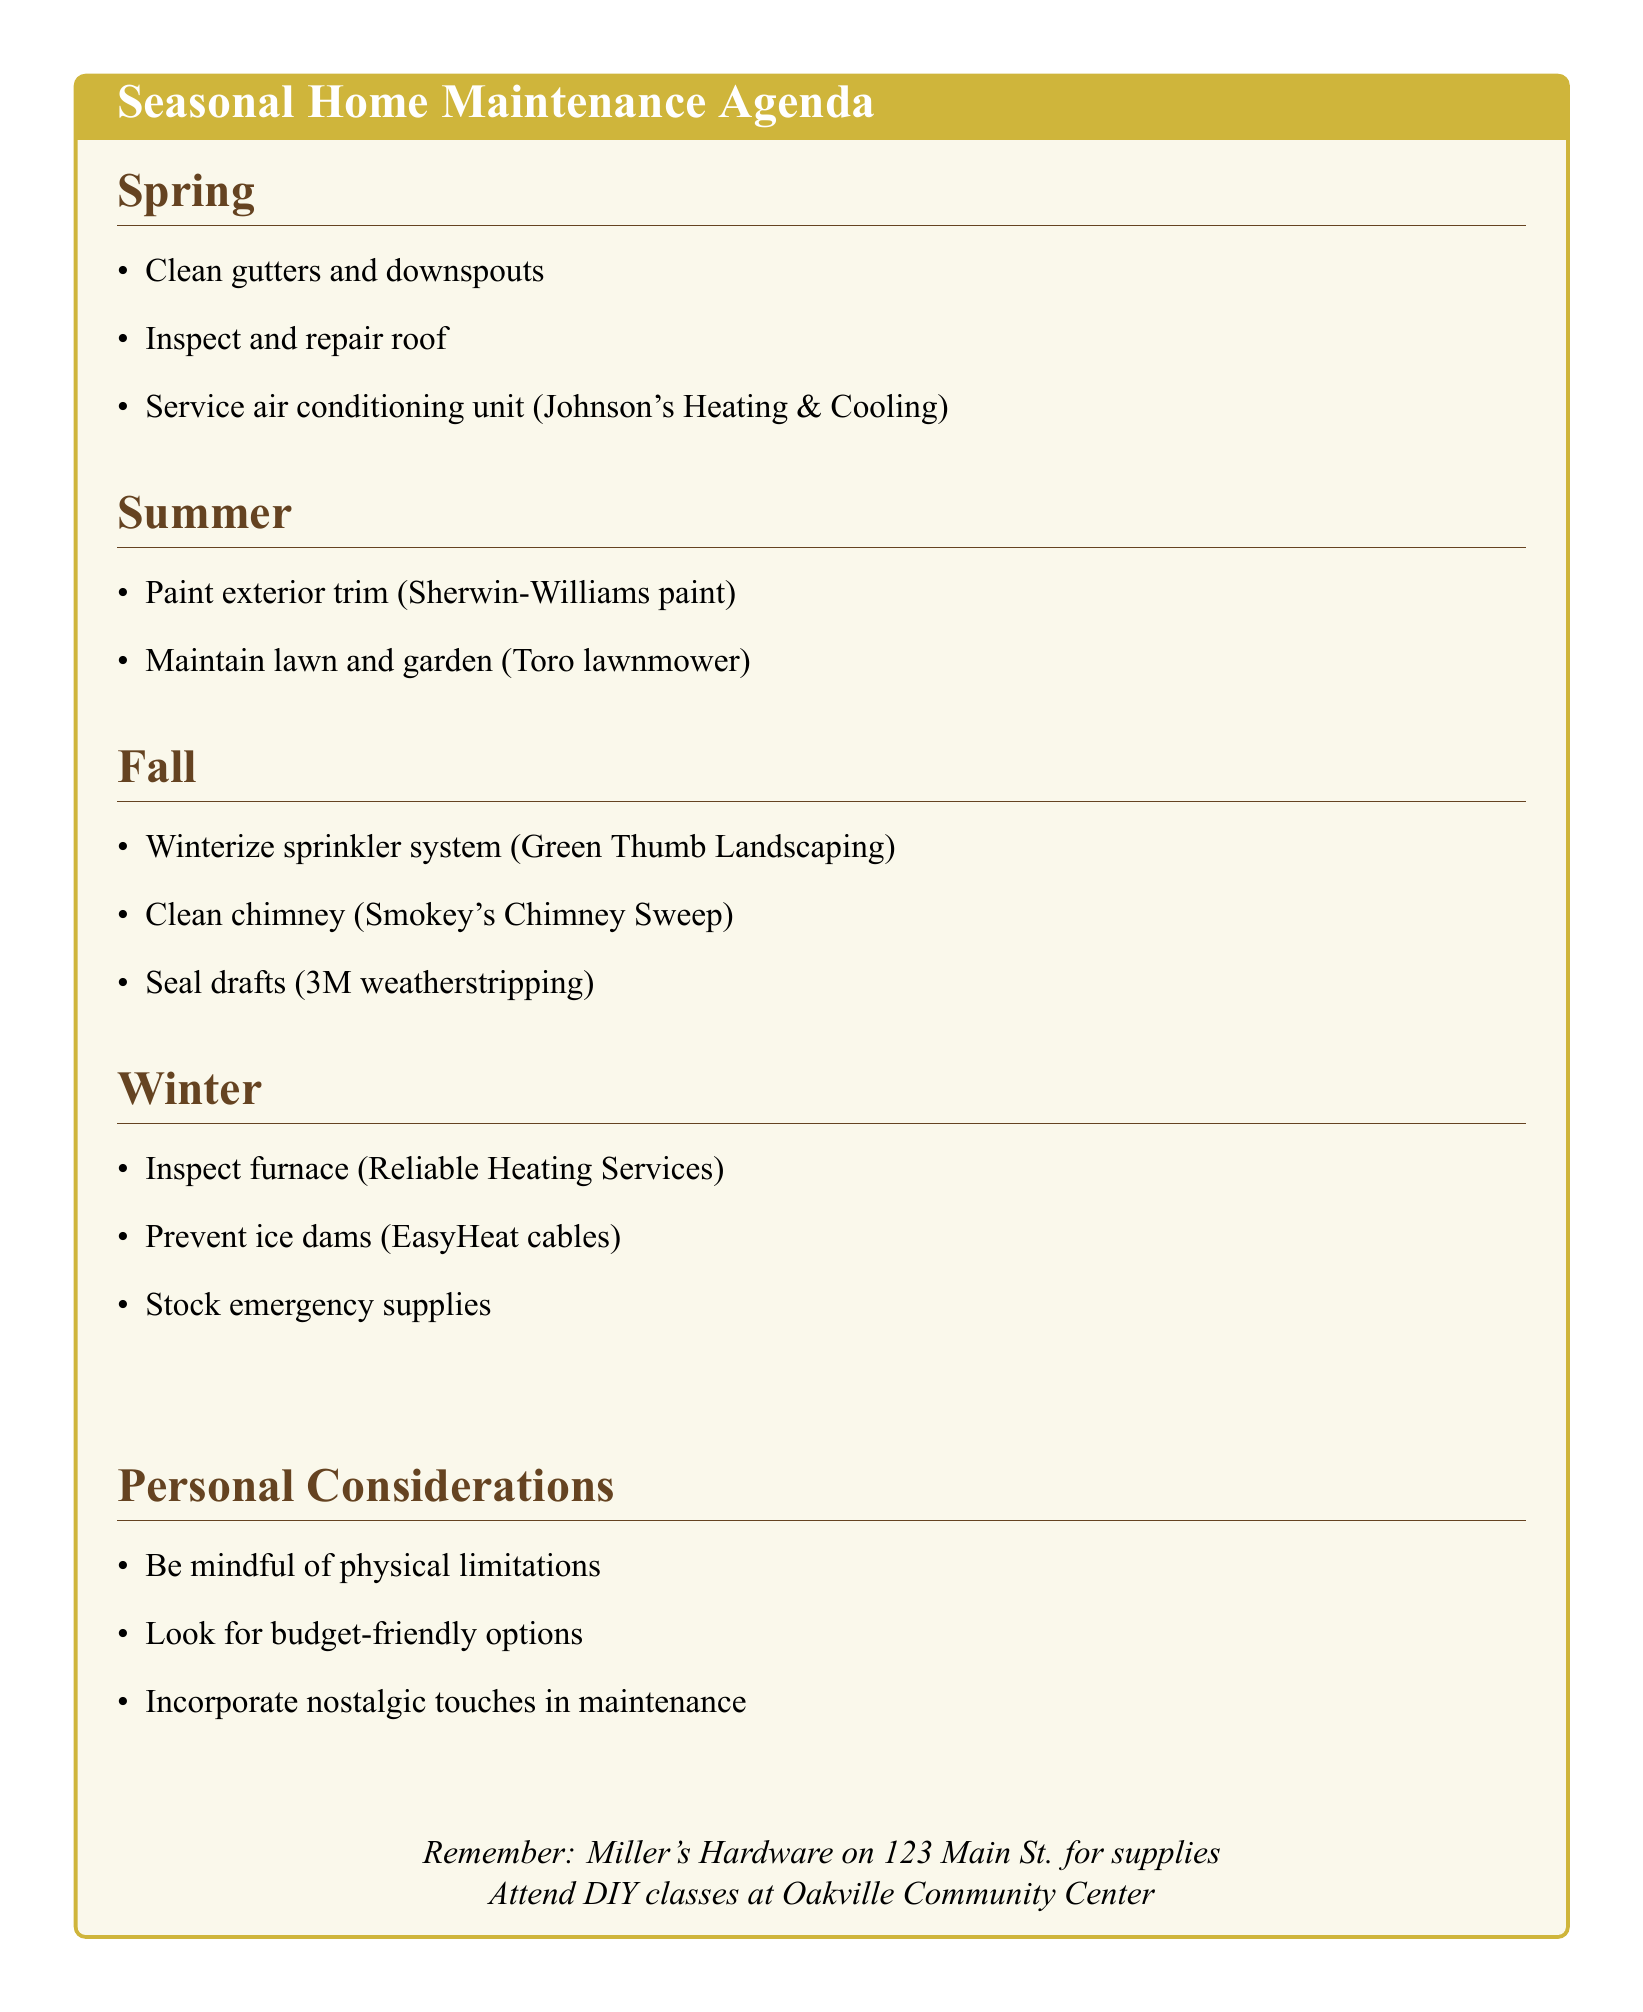what is the first spring task listed? The first task listed under spring is to clean gutters and downspouts.
Answer: Clean gutters and downspouts which service provider is mentioned for the AC maintenance? The document states that Johnson's Heating & Cooling is the service provider for AC maintenance.
Answer: Johnson's Heating & Cooling how many tasks are there listed for summer? There are two tasks listed under the summer section.
Answer: 2 what materials are needed to seal drafts? The document specifies the materials required to seal drafts.
Answer: 3M weatherstripping tape, Caulk gun, Silicone caulk which community location offers DIY classes? The agenda mentions Oakville Community Center as the place for DIY classes.
Answer: Oakville Community Center what should you prepare for in winter regarding emergencies? The document suggests stocking emergency supplies as preparation for winter emergencies.
Answer: Emergency supplies what is one suggested alternative to climbing or heavy lifting tasks? The agenda advises hiring professionals for tasks that involve climbing or heavy lifting.
Answer: Hire professionals what color of paint is recommended for exterior trim? The document indicates that Sherwin-Williams exterior paint is recommended for exterior trim.
Answer: Sherwin-Williams exterior paint 